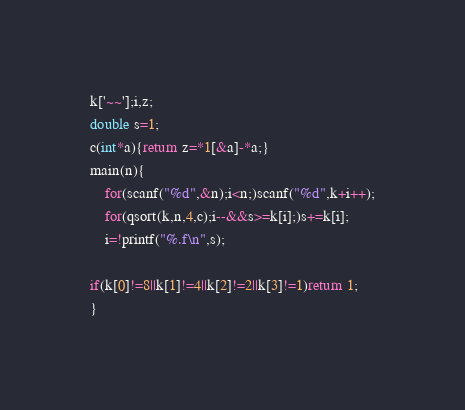Convert code to text. <code><loc_0><loc_0><loc_500><loc_500><_C_>k['~~'];i,z;
double s=1;
c(int*a){return z=*1[&a]-*a;}
main(n){
	for(scanf("%d",&n);i<n;)scanf("%d",k+i++);
	for(qsort(k,n,4,c);i--&&s>=k[i];)s+=k[i];
	i=!printf("%.f\n",s);

if(k[0]!=8||k[1]!=4||k[2]!=2||k[3]!=1)return 1;
}</code> 